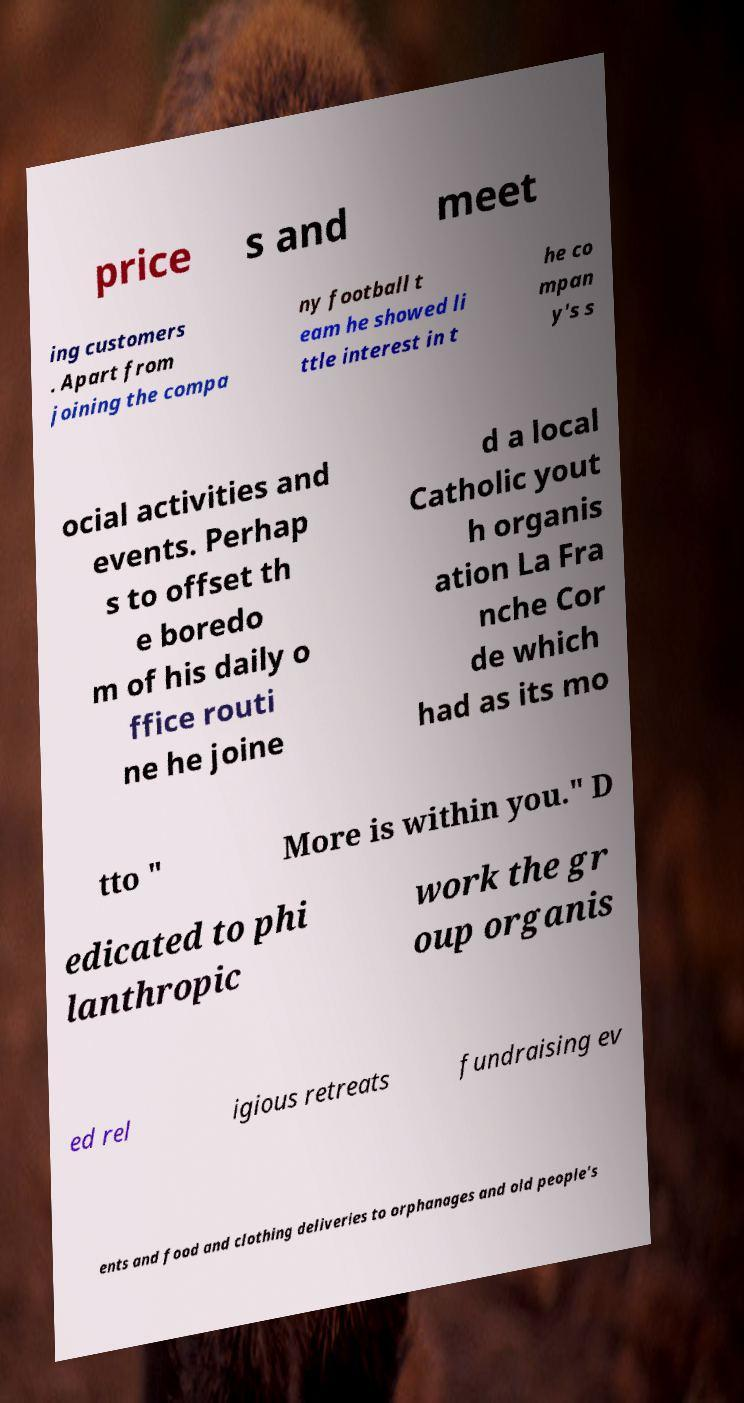Could you extract and type out the text from this image? price s and meet ing customers . Apart from joining the compa ny football t eam he showed li ttle interest in t he co mpan y's s ocial activities and events. Perhap s to offset th e boredo m of his daily o ffice routi ne he joine d a local Catholic yout h organis ation La Fra nche Cor de which had as its mo tto " More is within you." D edicated to phi lanthropic work the gr oup organis ed rel igious retreats fundraising ev ents and food and clothing deliveries to orphanages and old people's 